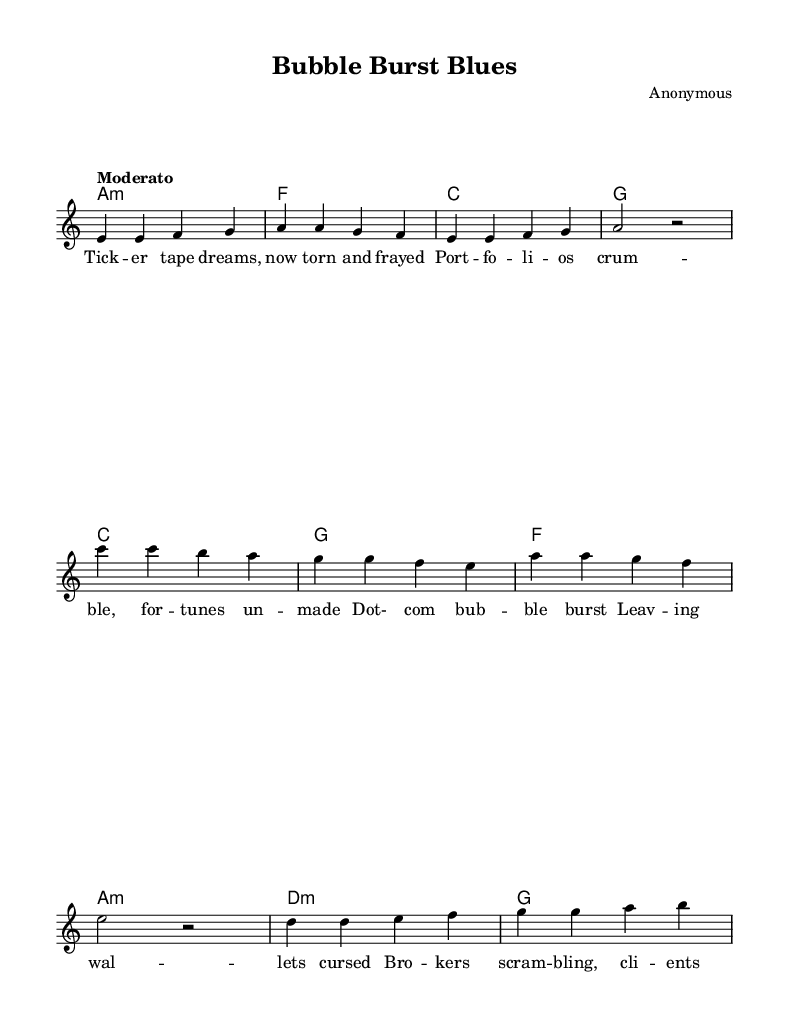What is the key signature of this music? The key signature is shown with one flat (B), indicating it is in the key of A minor.
Answer: A minor What is the time signature of this music? The time signature is indicated at the beginning with a "4/4" marking, which signifies four beats in each measure.
Answer: 4/4 What is the tempo marking of this piece? The tempo is indicated by the word "Moderato," which gives a sense of the speed of the piece.
Answer: Moderato How many measures are in the verse section? The verse consists of two lines of lyrics, each containing four measures, totaling eight measures in the verse section.
Answer: 8 What are the chord choices for the chorus? In the chorus, the chords are C, G, F, and A minor, following the progression displayed above the lyrics.
Answer: C, G, F, A minor What are the lyrics in the bridge section? The bridge lyrics are "But we'll rise again, from the ashes of greed," which provide a contrasting message to the previous sections.
Answer: But we'll rise again, from the ashes of greed How do the verses and chorus contrast musically? The verses use a minor chord foundation with a reflective mood, while the chorus shifts to a more dynamic pace with hopeful lyrics and major chords.
Answer: Verses are minor; chorus is major 